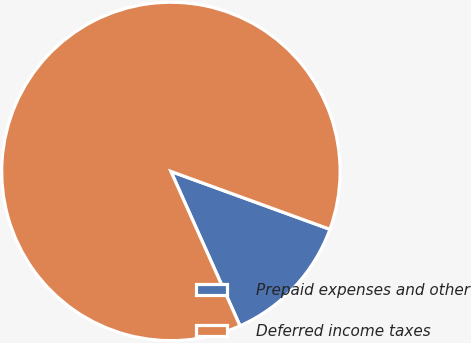<chart> <loc_0><loc_0><loc_500><loc_500><pie_chart><fcel>Prepaid expenses and other<fcel>Deferred income taxes<nl><fcel>12.75%<fcel>87.25%<nl></chart> 